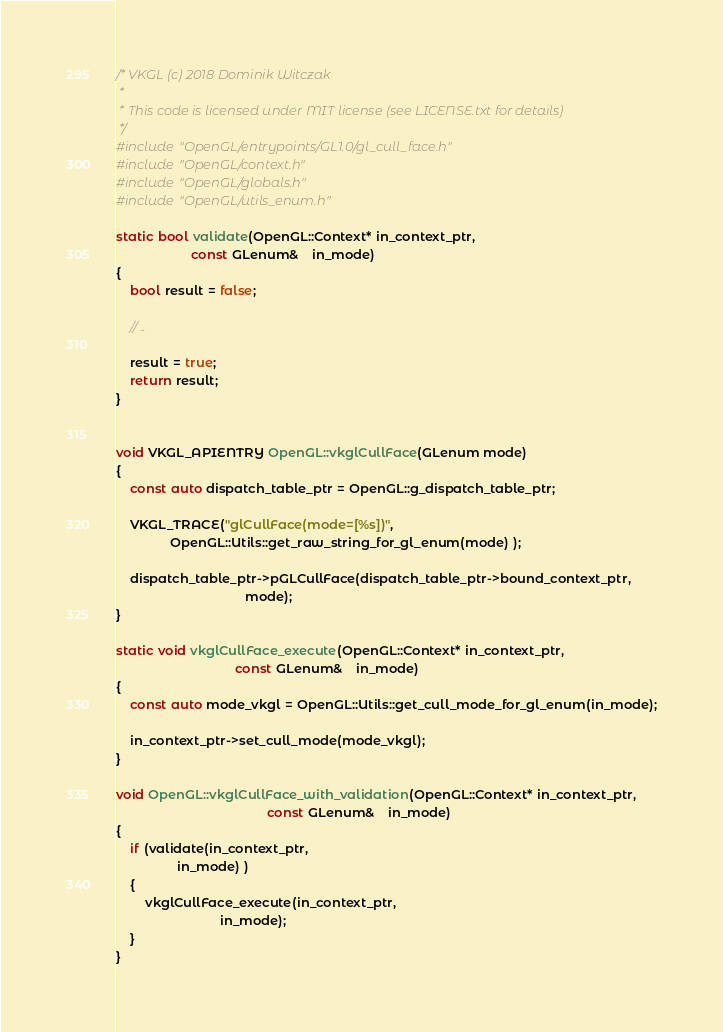Convert code to text. <code><loc_0><loc_0><loc_500><loc_500><_C++_>/* VKGL (c) 2018 Dominik Witczak
 *
 * This code is licensed under MIT license (see LICENSE.txt for details)
 */
#include "OpenGL/entrypoints/GL1.0/gl_cull_face.h"
#include "OpenGL/context.h"
#include "OpenGL/globals.h"
#include "OpenGL/utils_enum.h"

static bool validate(OpenGL::Context* in_context_ptr,
                     const GLenum&    in_mode)
{
    bool result = false;

    // ..

    result = true;
    return result;
}


void VKGL_APIENTRY OpenGL::vkglCullFace(GLenum mode)
{
    const auto dispatch_table_ptr = OpenGL::g_dispatch_table_ptr;

    VKGL_TRACE("glCullFace(mode=[%s])",
               OpenGL::Utils::get_raw_string_for_gl_enum(mode) );

    dispatch_table_ptr->pGLCullFace(dispatch_table_ptr->bound_context_ptr,
                                    mode);
}

static void vkglCullFace_execute(OpenGL::Context* in_context_ptr,
                                 const GLenum&    in_mode)
{
    const auto mode_vkgl = OpenGL::Utils::get_cull_mode_for_gl_enum(in_mode);

    in_context_ptr->set_cull_mode(mode_vkgl);
}

void OpenGL::vkglCullFace_with_validation(OpenGL::Context* in_context_ptr,
                                          const GLenum&    in_mode)
{
    if (validate(in_context_ptr,
                 in_mode) )
    {
        vkglCullFace_execute(in_context_ptr,
                             in_mode);
    }
}</code> 